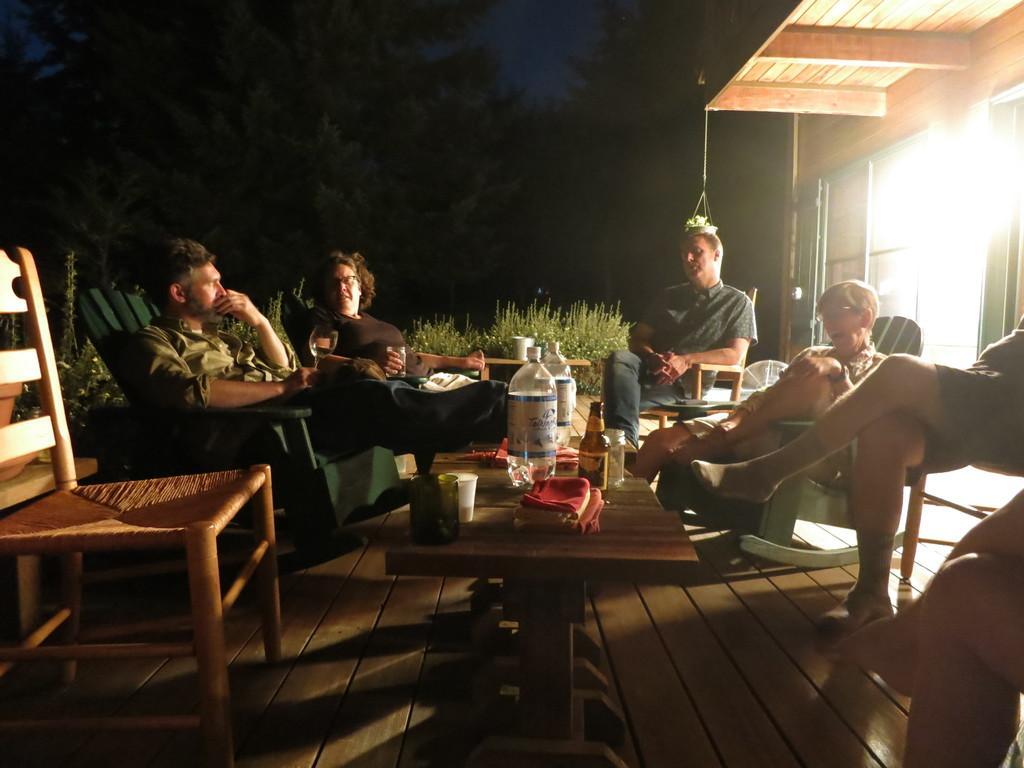Please provide a concise description of this image. This image is clicked outside. There are trees on the top and there is building on the right top corner. There is a table and chairs. People are sitting on chairs around the table. On that table there is water bottle, cup, napkin. 